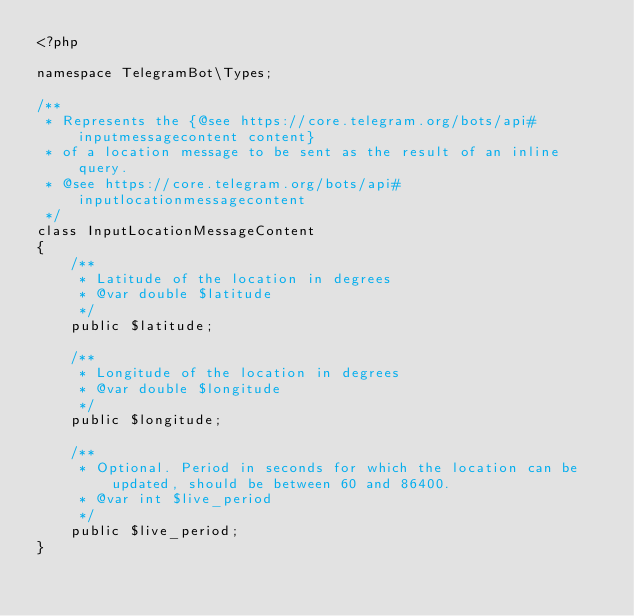Convert code to text. <code><loc_0><loc_0><loc_500><loc_500><_PHP_><?php

namespace TelegramBot\Types;

/**
 * Represents the {@see https://core.telegram.org/bots/api#inputmessagecontent content}
 * of a location message to be sent as the result of an inline query.
 * @see https://core.telegram.org/bots/api#inputlocationmessagecontent
 */
class InputLocationMessageContent
{
    /**
     * Latitude of the location in degrees
     * @var double $latitude
     */
    public $latitude;
    
    /**
     * Longitude of the location in degrees
     * @var double $longitude
     */
    public $longitude;
    
    /**
     * Optional. Period in seconds for which the location can be updated, should be between 60 and 86400.
     * @var int $live_period
     */
    public $live_period;
}
</code> 